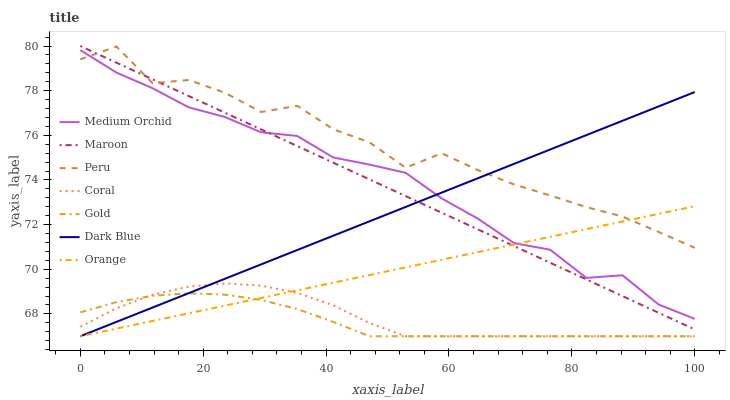Does Gold have the minimum area under the curve?
Answer yes or no. Yes. Does Peru have the maximum area under the curve?
Answer yes or no. Yes. Does Coral have the minimum area under the curve?
Answer yes or no. No. Does Coral have the maximum area under the curve?
Answer yes or no. No. Is Maroon the smoothest?
Answer yes or no. Yes. Is Peru the roughest?
Answer yes or no. Yes. Is Coral the smoothest?
Answer yes or no. No. Is Coral the roughest?
Answer yes or no. No. Does Gold have the lowest value?
Answer yes or no. Yes. Does Medium Orchid have the lowest value?
Answer yes or no. No. Does Maroon have the highest value?
Answer yes or no. Yes. Does Coral have the highest value?
Answer yes or no. No. Is Gold less than Maroon?
Answer yes or no. Yes. Is Maroon greater than Gold?
Answer yes or no. Yes. Does Medium Orchid intersect Maroon?
Answer yes or no. Yes. Is Medium Orchid less than Maroon?
Answer yes or no. No. Is Medium Orchid greater than Maroon?
Answer yes or no. No. Does Gold intersect Maroon?
Answer yes or no. No. 